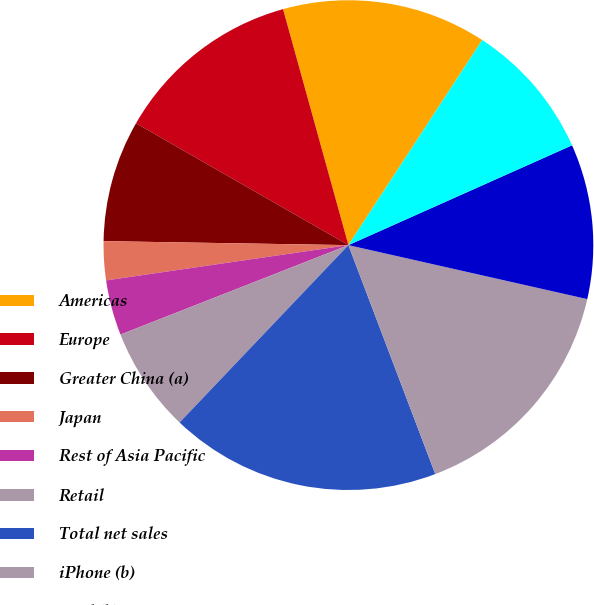<chart> <loc_0><loc_0><loc_500><loc_500><pie_chart><fcel>Americas<fcel>Europe<fcel>Greater China (a)<fcel>Japan<fcel>Rest of Asia Pacific<fcel>Retail<fcel>Total net sales<fcel>iPhone (b)<fcel>iPad (b)<fcel>Mac (b)<nl><fcel>13.5%<fcel>12.41%<fcel>8.03%<fcel>2.56%<fcel>3.65%<fcel>6.94%<fcel>17.88%<fcel>15.69%<fcel>10.22%<fcel>9.12%<nl></chart> 